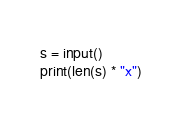<code> <loc_0><loc_0><loc_500><loc_500><_Python_>s = input()
print(len(s) * "x")</code> 